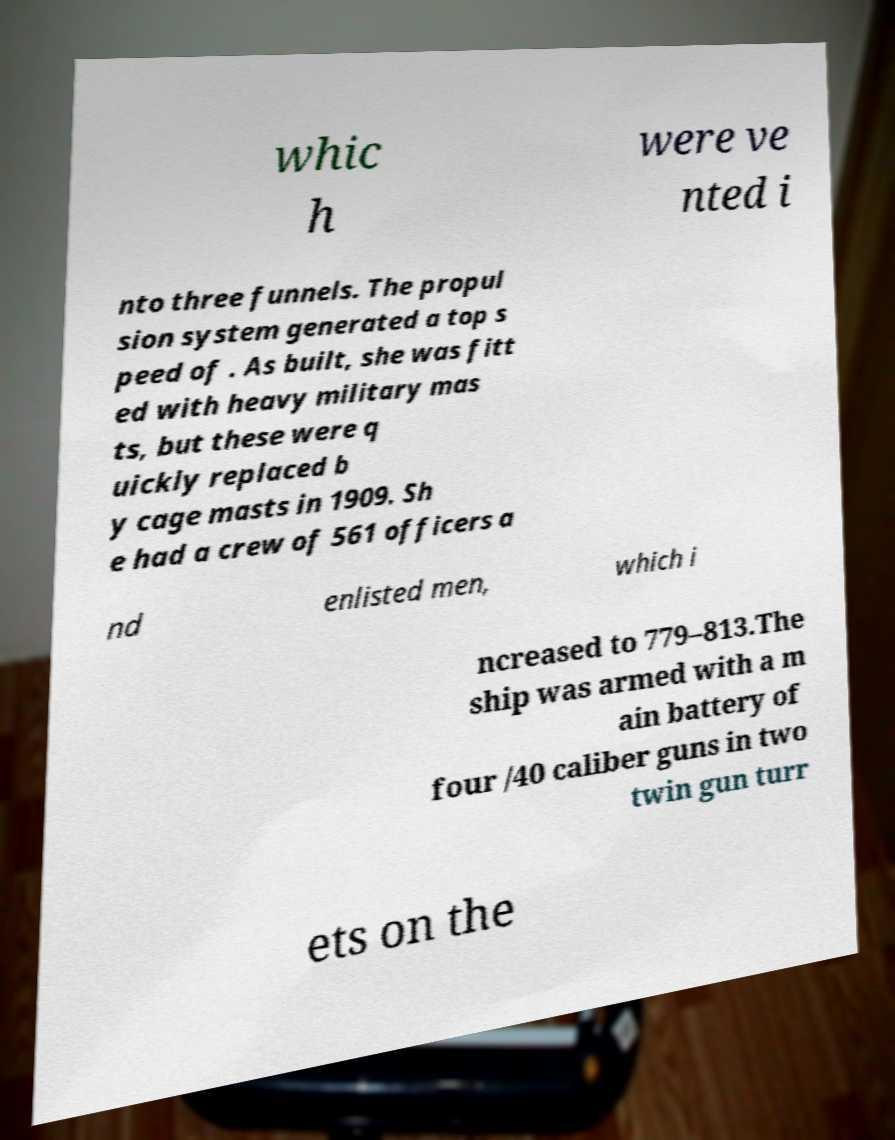What messages or text are displayed in this image? I need them in a readable, typed format. whic h were ve nted i nto three funnels. The propul sion system generated a top s peed of . As built, she was fitt ed with heavy military mas ts, but these were q uickly replaced b y cage masts in 1909. Sh e had a crew of 561 officers a nd enlisted men, which i ncreased to 779–813.The ship was armed with a m ain battery of four /40 caliber guns in two twin gun turr ets on the 